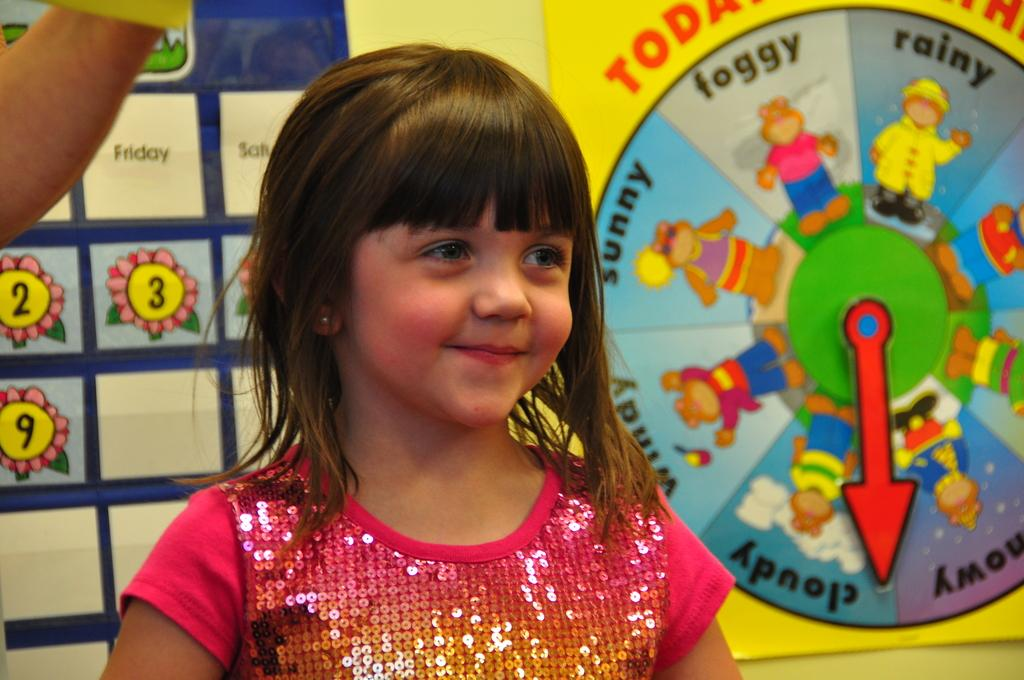What is the main subject of the image? There is a small child in the image. Can you describe anything else in the image? There is a person's hand in the top left corner of the image, and there are posters in the background of the image. What type of range can be seen in the image? There is no range present in the image. Is the small child skating in the image? There is no indication of the small child skating in the image. 